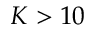<formula> <loc_0><loc_0><loc_500><loc_500>K > 1 0</formula> 